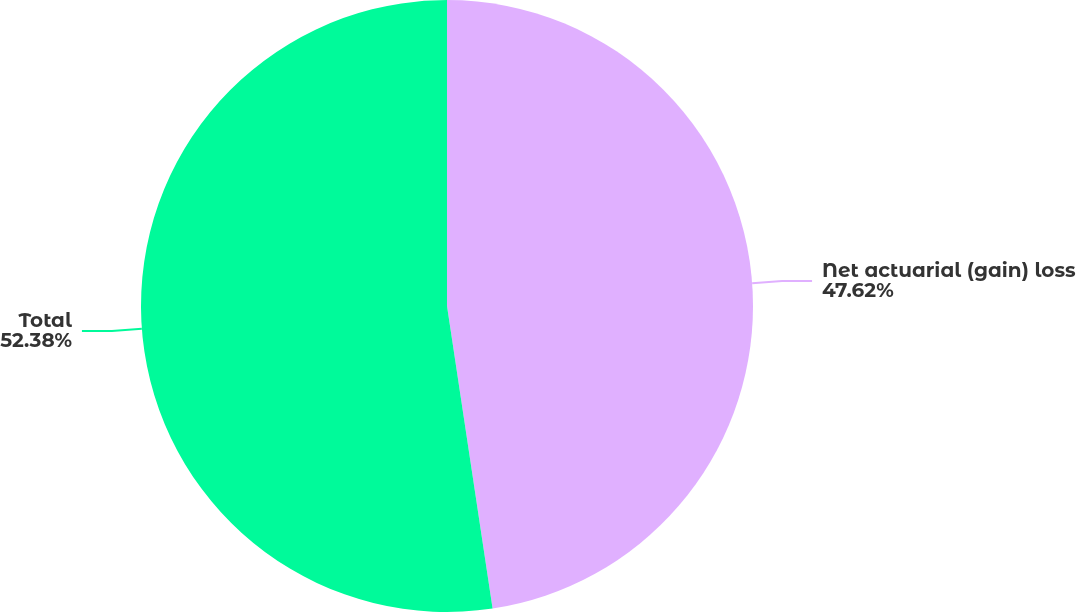<chart> <loc_0><loc_0><loc_500><loc_500><pie_chart><fcel>Net actuarial (gain) loss<fcel>Total<nl><fcel>47.62%<fcel>52.38%<nl></chart> 